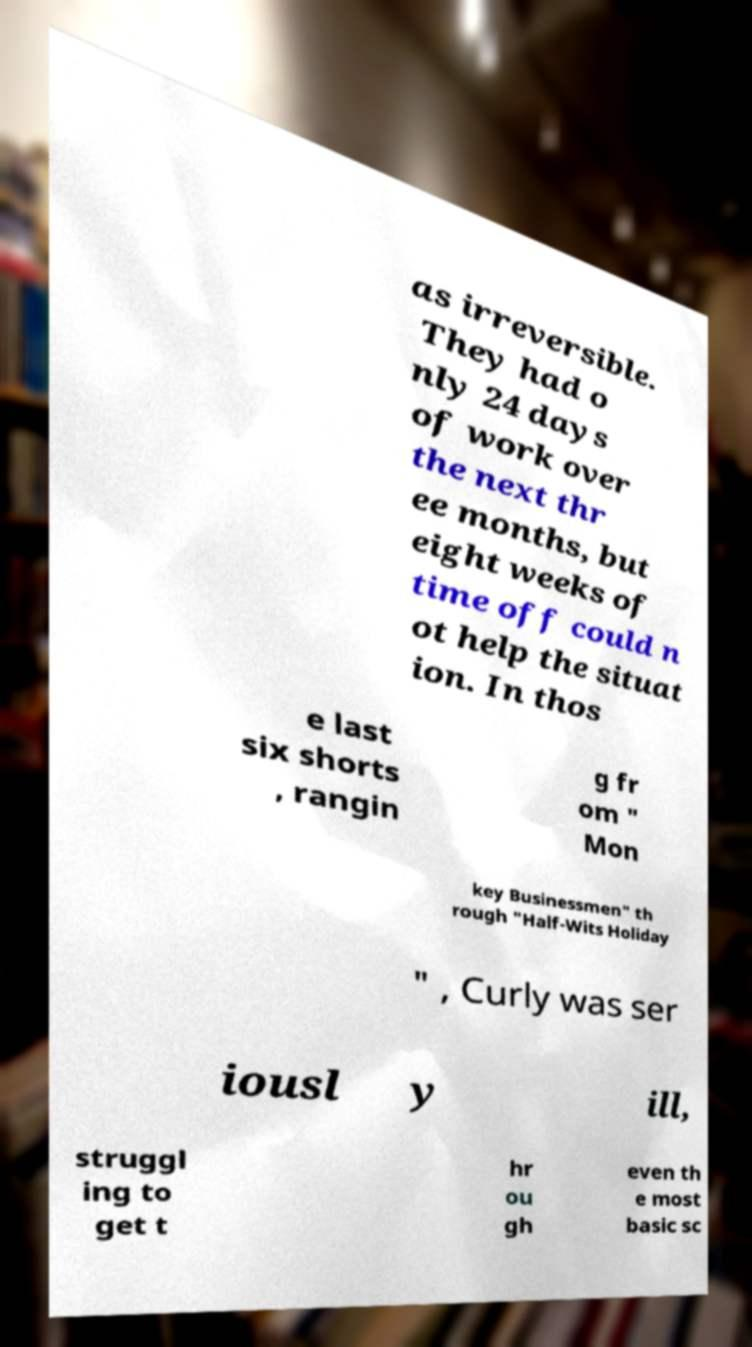I need the written content from this picture converted into text. Can you do that? as irreversible. They had o nly 24 days of work over the next thr ee months, but eight weeks of time off could n ot help the situat ion. In thos e last six shorts , rangin g fr om " Mon key Businessmen" th rough "Half-Wits Holiday " , Curly was ser iousl y ill, struggl ing to get t hr ou gh even th e most basic sc 